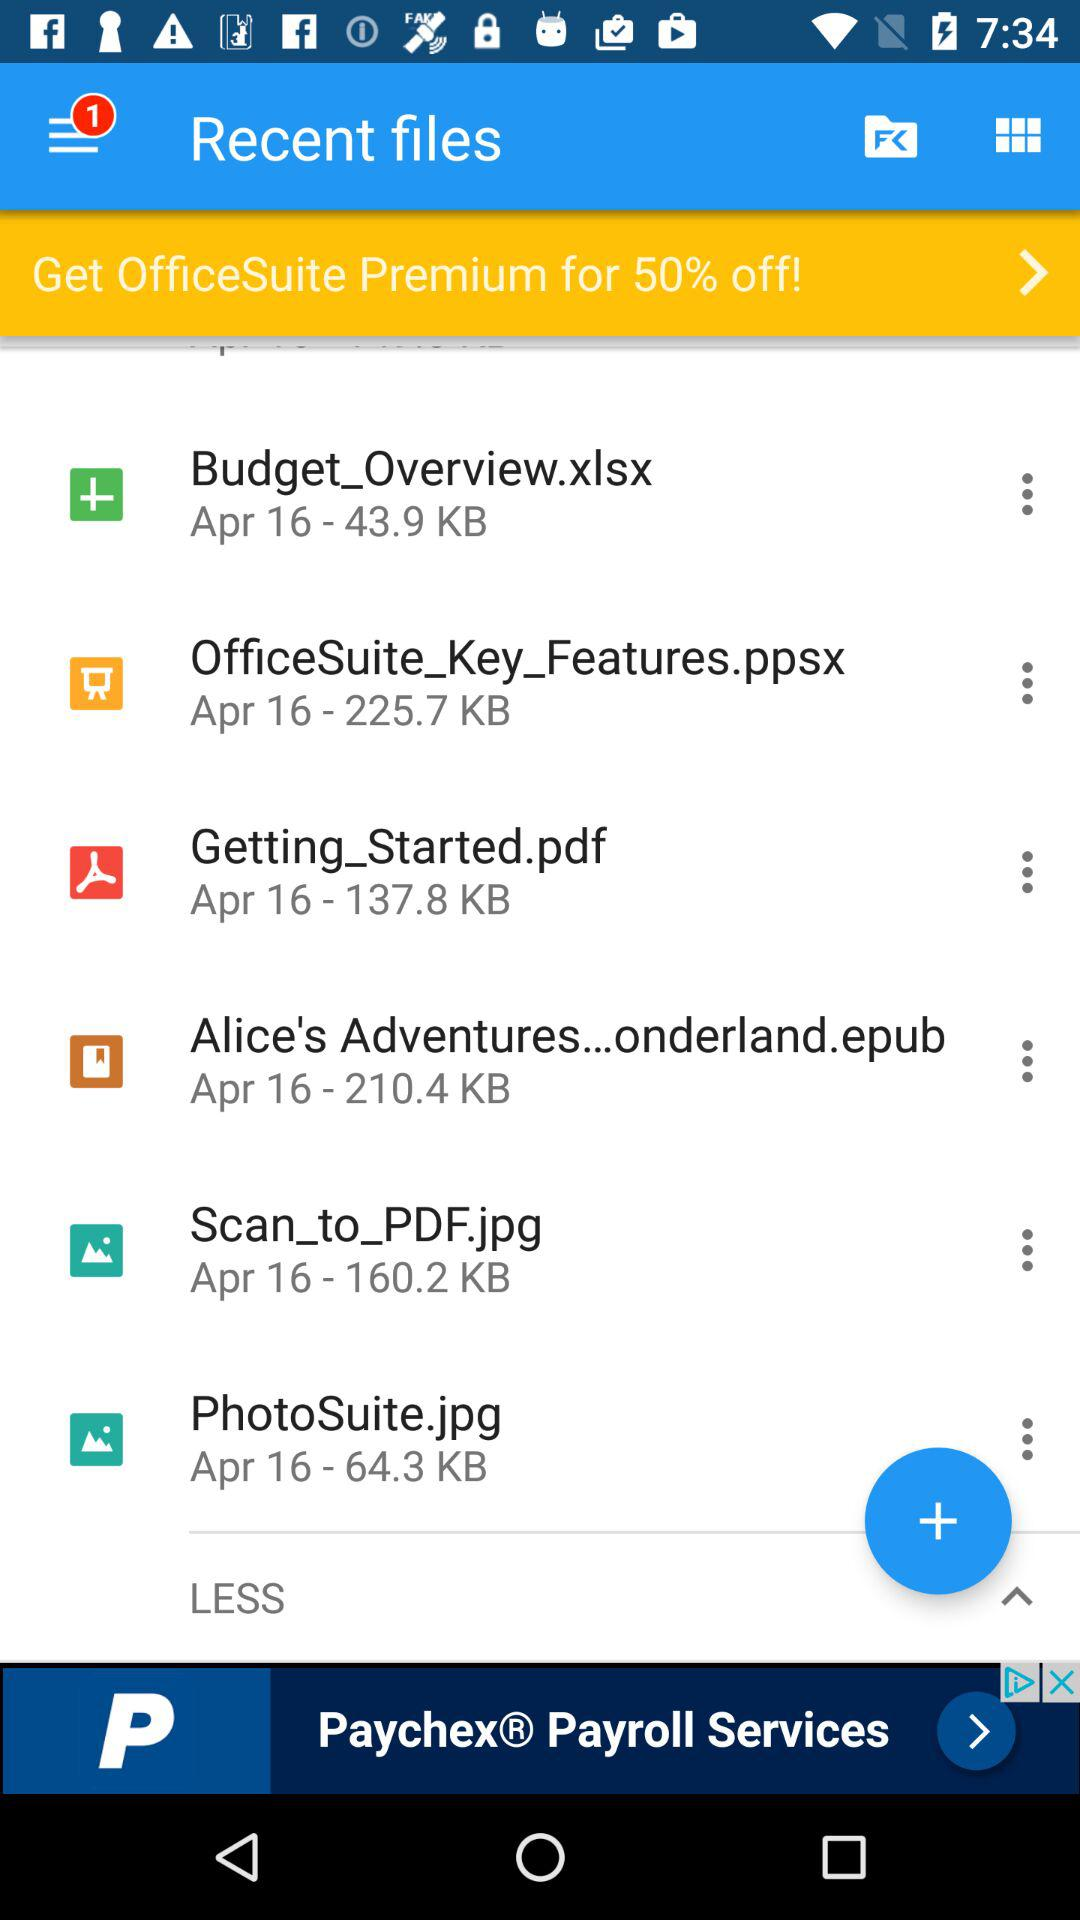Which file takes up 225.7 KB of space? The file that takes up 225.7 KB of space is "OfficeSuite_Key_Features.ppsx". 